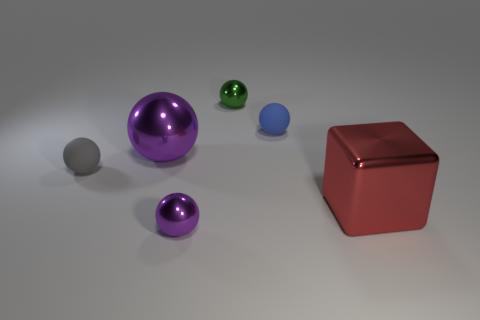Are there any big blue cylinders that have the same material as the big purple object? After reviewing the image, no big blue cylinders share the same material as the big purple object, which appears to be metallic. There is one large purple metallic sphere, a smaller metallic green sphere, a small blue sphere with a matte finish, and a metallic red cube. 